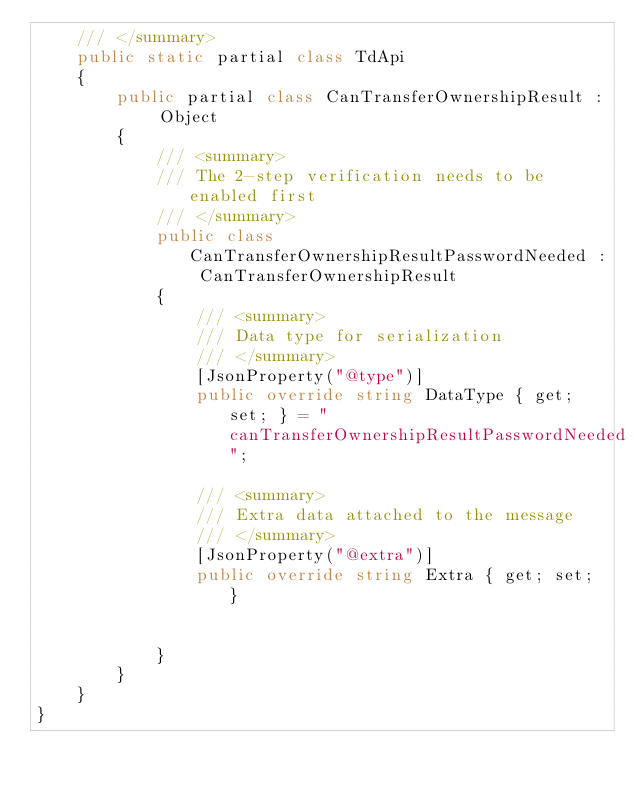Convert code to text. <code><loc_0><loc_0><loc_500><loc_500><_C#_>    /// </summary>
    public static partial class TdApi
    {
        public partial class CanTransferOwnershipResult : Object
        {
            /// <summary>
            /// The 2-step verification needs to be enabled first
            /// </summary>
            public class CanTransferOwnershipResultPasswordNeeded : CanTransferOwnershipResult
            {
                /// <summary>
                /// Data type for serialization
                /// </summary>
                [JsonProperty("@type")]
                public override string DataType { get; set; } = "canTransferOwnershipResultPasswordNeeded";

                /// <summary>
                /// Extra data attached to the message
                /// </summary>
                [JsonProperty("@extra")]
                public override string Extra { get; set; }


            }
        }
    }
}</code> 